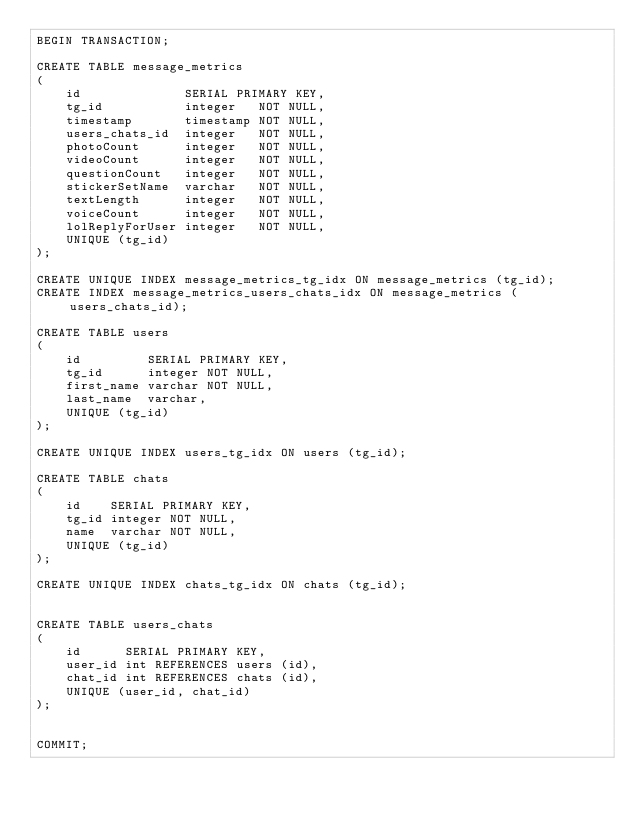Convert code to text. <code><loc_0><loc_0><loc_500><loc_500><_SQL_>BEGIN TRANSACTION;

CREATE TABLE message_metrics
(
    id              SERIAL PRIMARY KEY,
    tg_id           integer   NOT NULL,
    timestamp       timestamp NOT NULL,
    users_chats_id  integer   NOT NULL,
    photoCount      integer   NOT NULL,
    videoCount      integer   NOT NULL,
    questionCount   integer   NOT NULL,
    stickerSetName  varchar   NOT NULL,
    textLength      integer   NOT NULL,
    voiceCount      integer   NOT NULL,
    lolReplyForUser integer   NOT NULL,
    UNIQUE (tg_id)
);

CREATE UNIQUE INDEX message_metrics_tg_idx ON message_metrics (tg_id);
CREATE INDEX message_metrics_users_chats_idx ON message_metrics (users_chats_id);

CREATE TABLE users
(
    id         SERIAL PRIMARY KEY,
    tg_id      integer NOT NULL,
    first_name varchar NOT NULL,
    last_name  varchar,
    UNIQUE (tg_id)
);

CREATE UNIQUE INDEX users_tg_idx ON users (tg_id);

CREATE TABLE chats
(
    id    SERIAL PRIMARY KEY,
    tg_id integer NOT NULL,
    name  varchar NOT NULL,
    UNIQUE (tg_id)
);

CREATE UNIQUE INDEX chats_tg_idx ON chats (tg_id);


CREATE TABLE users_chats
(
    id      SERIAL PRIMARY KEY,
    user_id int REFERENCES users (id),
    chat_id int REFERENCES chats (id),
    UNIQUE (user_id, chat_id)
);


COMMIT;
</code> 